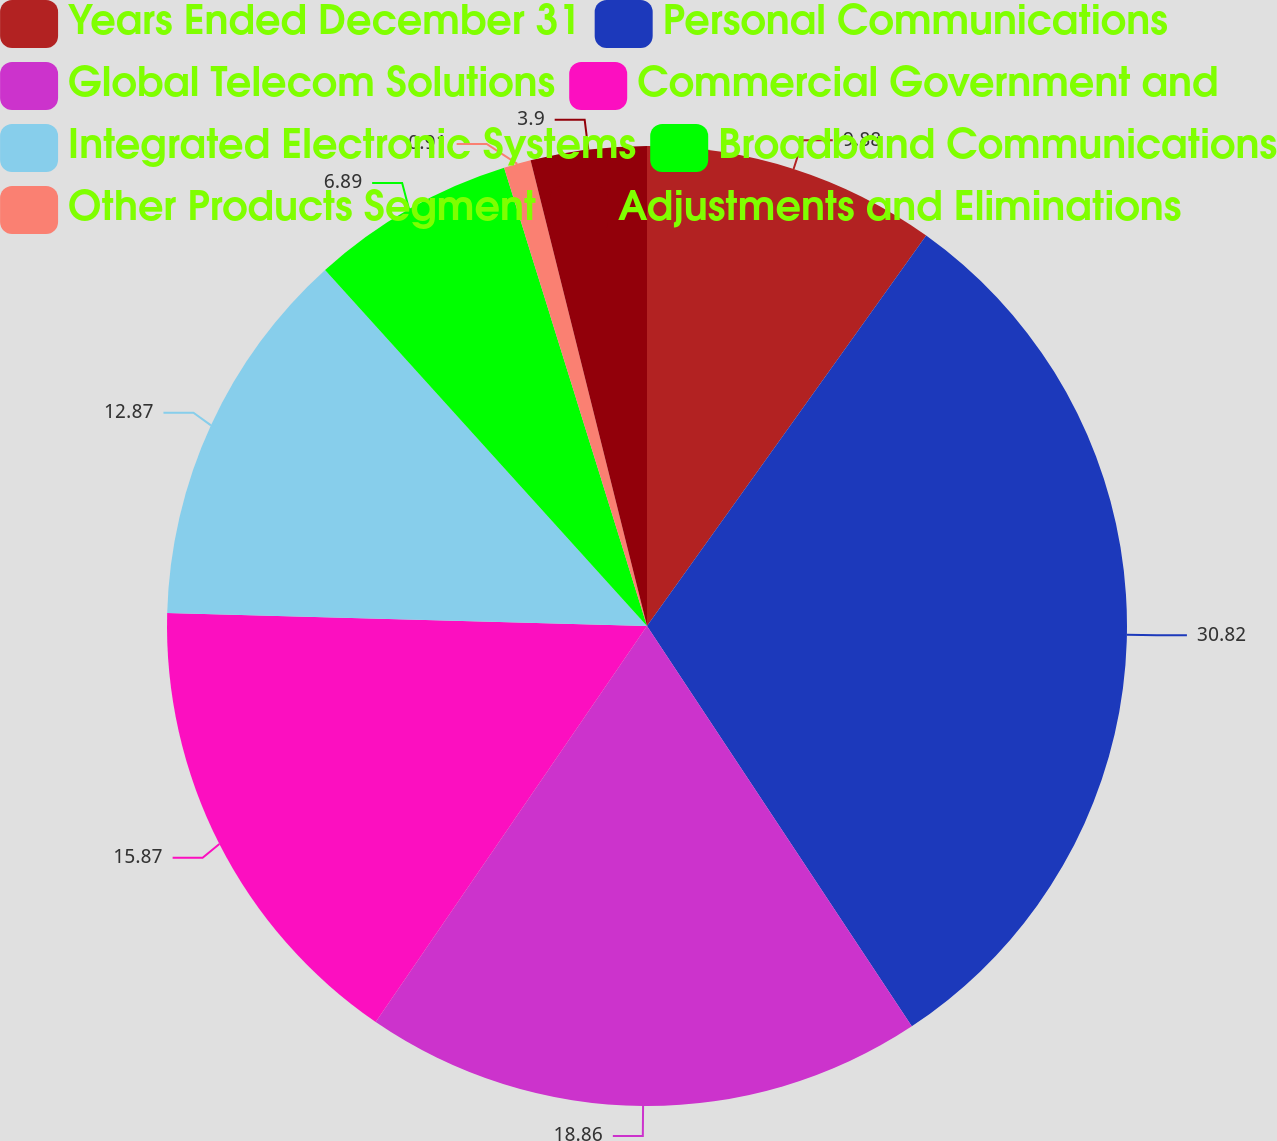Convert chart to OTSL. <chart><loc_0><loc_0><loc_500><loc_500><pie_chart><fcel>Years Ended December 31<fcel>Personal Communications<fcel>Global Telecom Solutions<fcel>Commercial Government and<fcel>Integrated Electronic Systems<fcel>Broadband Communications<fcel>Other Products Segment<fcel>Adjustments and Eliminations<nl><fcel>9.88%<fcel>30.82%<fcel>18.86%<fcel>15.87%<fcel>12.87%<fcel>6.89%<fcel>0.91%<fcel>3.9%<nl></chart> 